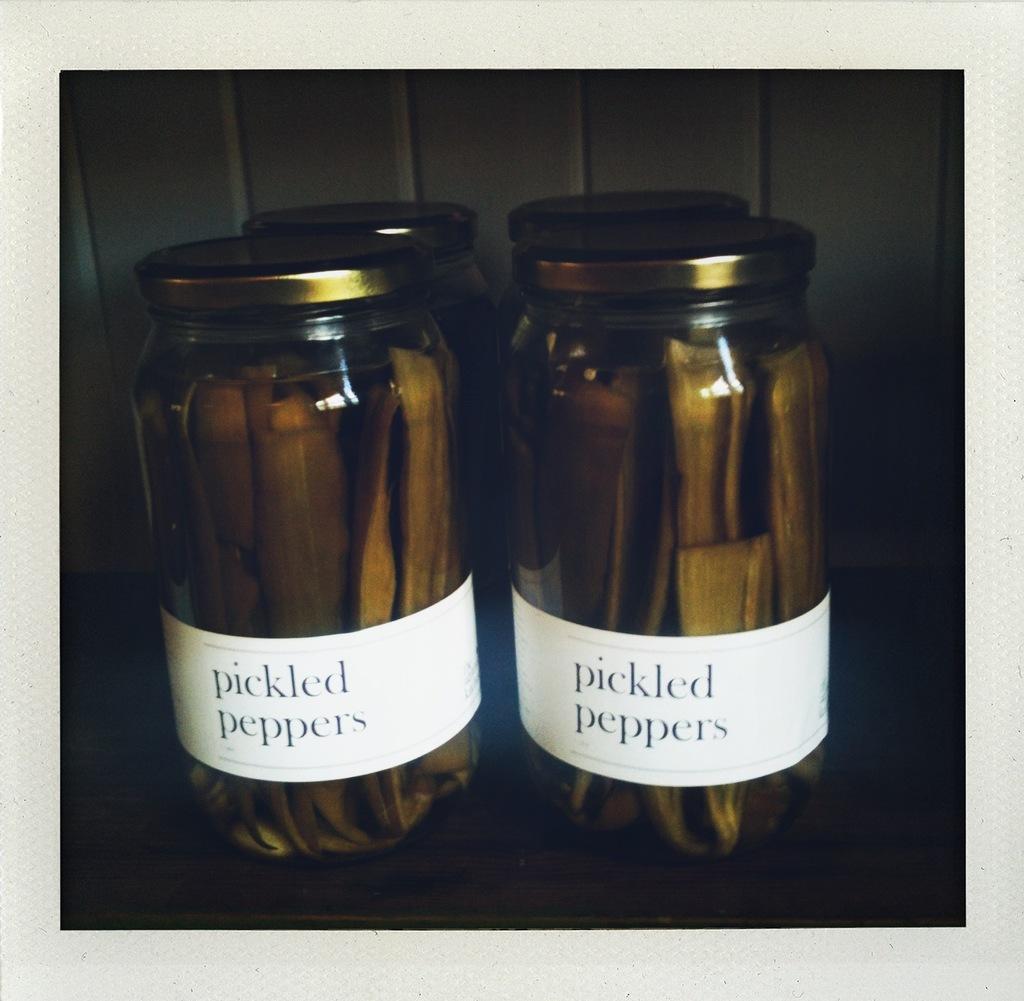What type of peppers are these?
Your response must be concise. Pickled. 